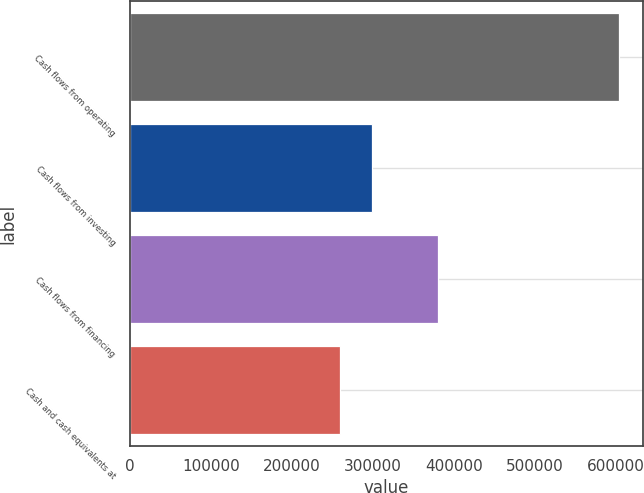Convert chart. <chart><loc_0><loc_0><loc_500><loc_500><bar_chart><fcel>Cash flows from operating<fcel>Cash flows from investing<fcel>Cash flows from financing<fcel>Cash and cash equivalents at<nl><fcel>603229<fcel>298458<fcel>379711<fcel>258693<nl></chart> 